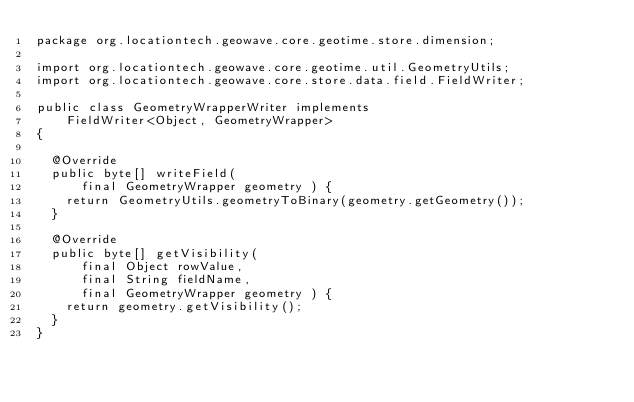<code> <loc_0><loc_0><loc_500><loc_500><_Java_>package org.locationtech.geowave.core.geotime.store.dimension;

import org.locationtech.geowave.core.geotime.util.GeometryUtils;
import org.locationtech.geowave.core.store.data.field.FieldWriter;

public class GeometryWrapperWriter implements
		FieldWriter<Object, GeometryWrapper>
{

	@Override
	public byte[] writeField(
			final GeometryWrapper geometry ) {
		return GeometryUtils.geometryToBinary(geometry.getGeometry());
	}

	@Override
	public byte[] getVisibility(
			final Object rowValue,
			final String fieldName,
			final GeometryWrapper geometry ) {
		return geometry.getVisibility();
	}
}
</code> 